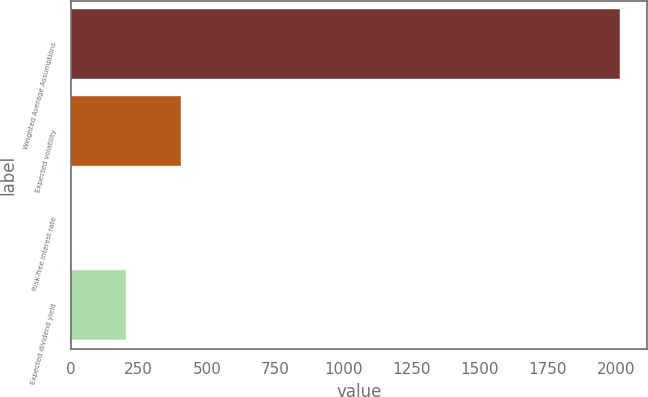<chart> <loc_0><loc_0><loc_500><loc_500><bar_chart><fcel>Weighted Average Assumptions<fcel>Expected volatility<fcel>Risk-free interest rate<fcel>Expected dividend yield<nl><fcel>2014<fcel>404.44<fcel>2.04<fcel>203.24<nl></chart> 